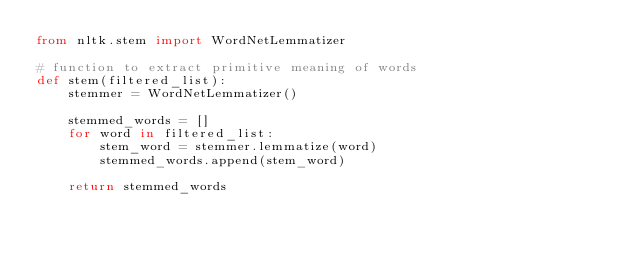<code> <loc_0><loc_0><loc_500><loc_500><_Python_>from nltk.stem import WordNetLemmatizer

# function to extract primitive meaning of words
def stem(filtered_list):
    stemmer = WordNetLemmatizer()
    
    stemmed_words = []
    for word in filtered_list: 
        stem_word = stemmer.lemmatize(word)
        stemmed_words.append(stem_word)

    return stemmed_words
    </code> 